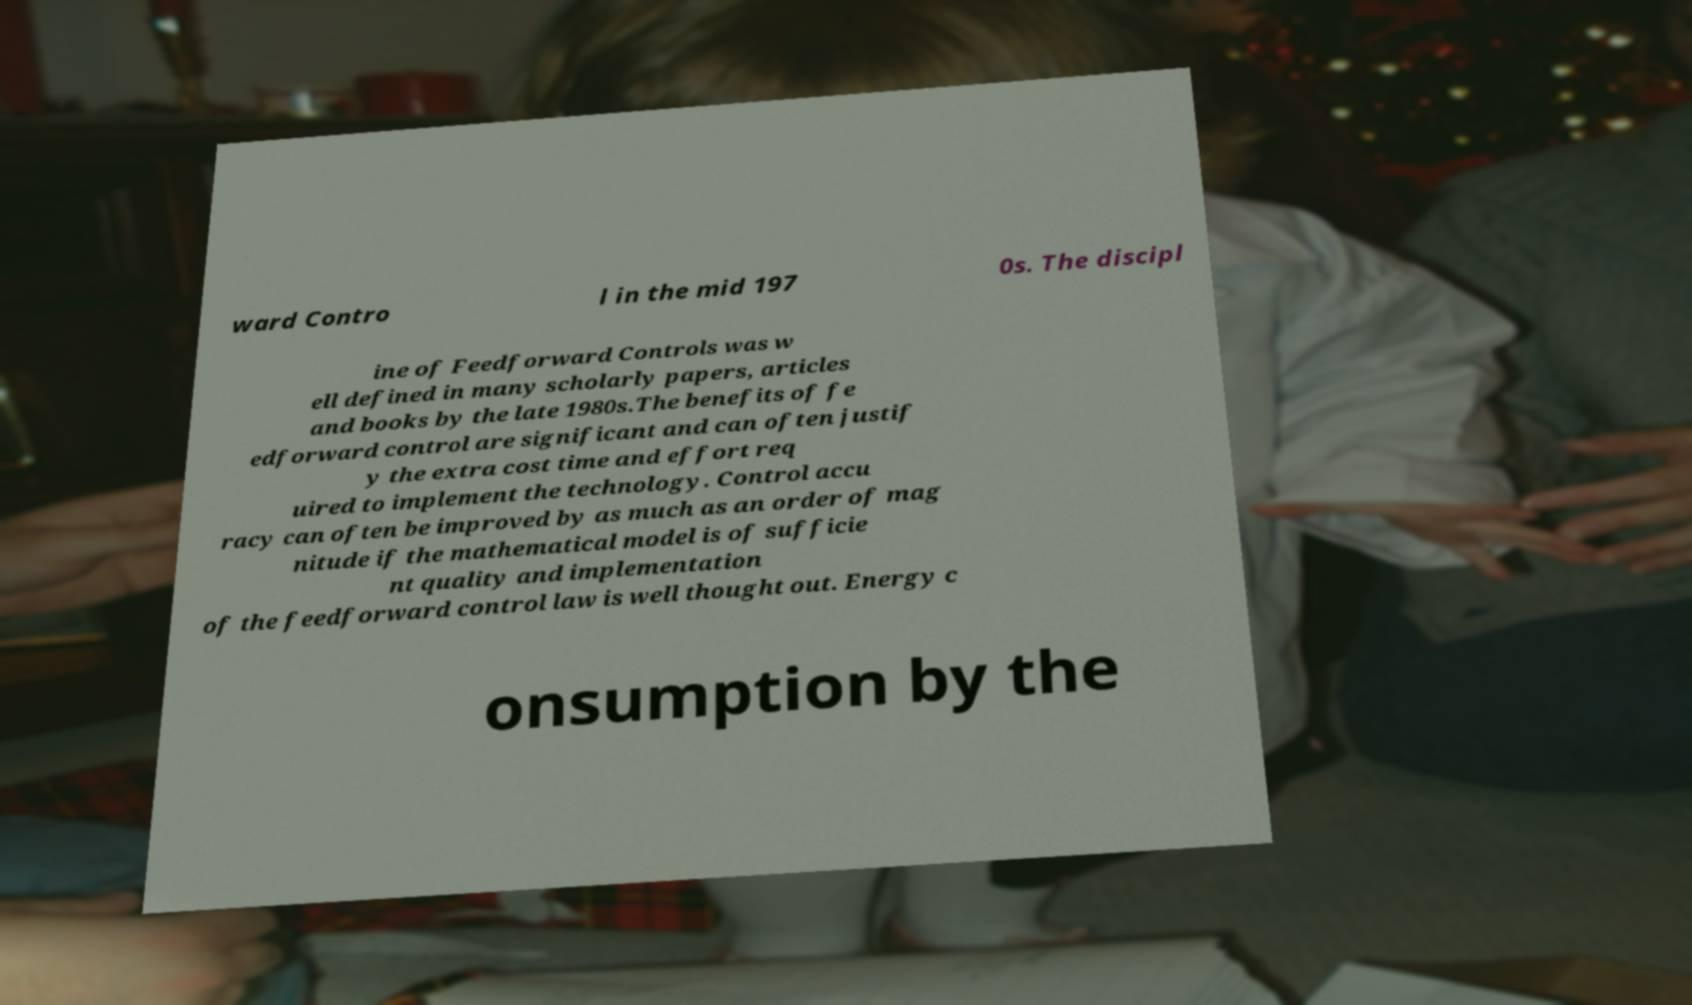Please read and relay the text visible in this image. What does it say? ward Contro l in the mid 197 0s. The discipl ine of Feedforward Controls was w ell defined in many scholarly papers, articles and books by the late 1980s.The benefits of fe edforward control are significant and can often justif y the extra cost time and effort req uired to implement the technology. Control accu racy can often be improved by as much as an order of mag nitude if the mathematical model is of sufficie nt quality and implementation of the feedforward control law is well thought out. Energy c onsumption by the 